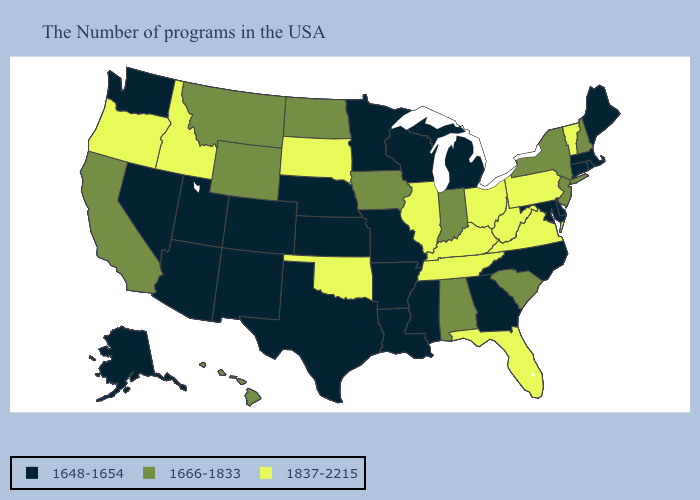What is the value of Florida?
Short answer required. 1837-2215. Does Louisiana have a lower value than Wisconsin?
Give a very brief answer. No. What is the highest value in the USA?
Be succinct. 1837-2215. Name the states that have a value in the range 1837-2215?
Concise answer only. Vermont, Pennsylvania, Virginia, West Virginia, Ohio, Florida, Kentucky, Tennessee, Illinois, Oklahoma, South Dakota, Idaho, Oregon. Name the states that have a value in the range 1666-1833?
Keep it brief. New Hampshire, New York, New Jersey, South Carolina, Indiana, Alabama, Iowa, North Dakota, Wyoming, Montana, California, Hawaii. What is the lowest value in the MidWest?
Keep it brief. 1648-1654. Among the states that border New Mexico , which have the lowest value?
Concise answer only. Texas, Colorado, Utah, Arizona. What is the lowest value in states that border Montana?
Short answer required. 1666-1833. Name the states that have a value in the range 1837-2215?
Quick response, please. Vermont, Pennsylvania, Virginia, West Virginia, Ohio, Florida, Kentucky, Tennessee, Illinois, Oklahoma, South Dakota, Idaho, Oregon. What is the highest value in the USA?
Keep it brief. 1837-2215. What is the value of Oregon?
Write a very short answer. 1837-2215. Does Idaho have the same value as South Dakota?
Be succinct. Yes. Among the states that border Arizona , which have the highest value?
Quick response, please. California. 